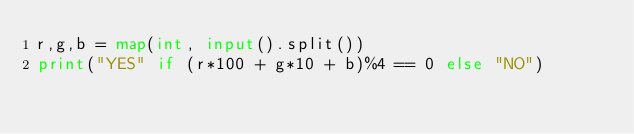Convert code to text. <code><loc_0><loc_0><loc_500><loc_500><_Python_>r,g,b = map(int, input().split())
print("YES" if (r*100 + g*10 + b)%4 == 0 else "NO")</code> 